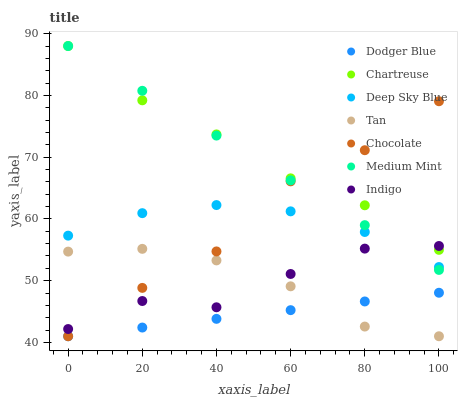Does Dodger Blue have the minimum area under the curve?
Answer yes or no. Yes. Does Chartreuse have the maximum area under the curve?
Answer yes or no. Yes. Does Indigo have the minimum area under the curve?
Answer yes or no. No. Does Indigo have the maximum area under the curve?
Answer yes or no. No. Is Dodger Blue the smoothest?
Answer yes or no. Yes. Is Indigo the roughest?
Answer yes or no. Yes. Is Chocolate the smoothest?
Answer yes or no. No. Is Chocolate the roughest?
Answer yes or no. No. Does Chocolate have the lowest value?
Answer yes or no. Yes. Does Indigo have the lowest value?
Answer yes or no. No. Does Chartreuse have the highest value?
Answer yes or no. Yes. Does Indigo have the highest value?
Answer yes or no. No. Is Tan less than Deep Sky Blue?
Answer yes or no. Yes. Is Deep Sky Blue greater than Dodger Blue?
Answer yes or no. Yes. Does Tan intersect Indigo?
Answer yes or no. Yes. Is Tan less than Indigo?
Answer yes or no. No. Is Tan greater than Indigo?
Answer yes or no. No. Does Tan intersect Deep Sky Blue?
Answer yes or no. No. 